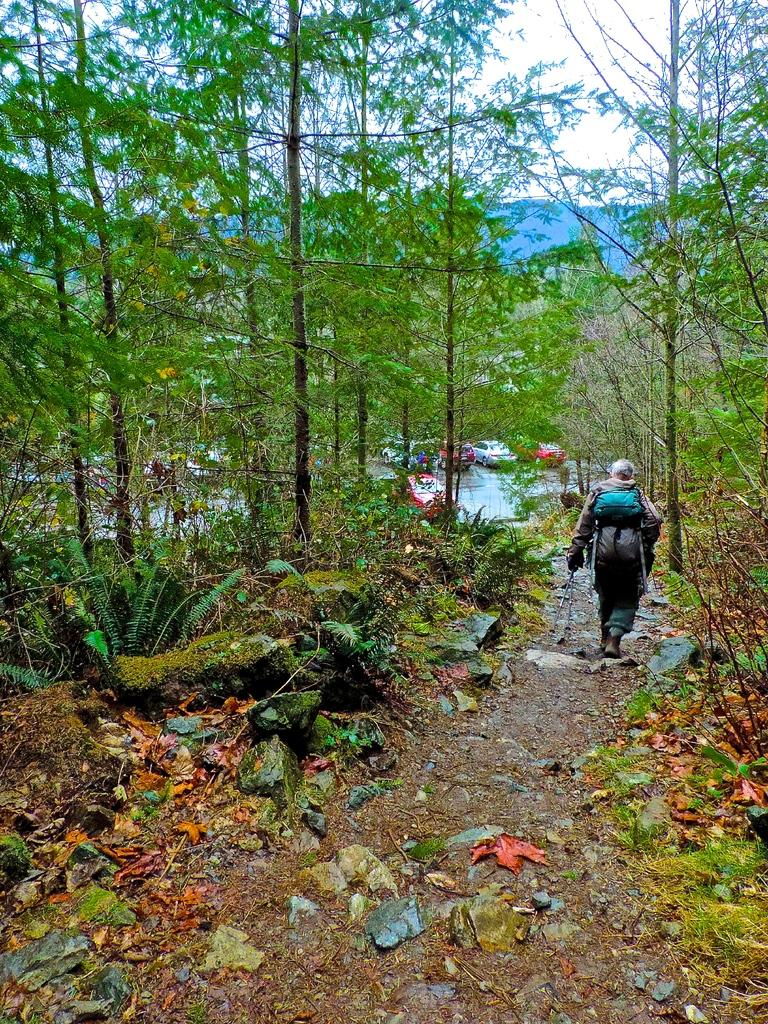Who is present in the image? There is a person in the image. What is the person doing in the image? The person is walking on a path. What is the person carrying while walking on the path? The person is carrying a backpack. What can be seen on both sides of the path in the image? There are trees on both sides of the path. What is visible in the background of the image? There are parked cars in the background of the image. What type of square is being used for arithmetic calculations in the image? There is no square or arithmetic calculations present in the image. How many feet does the person have in the image? The image does not show the person's feet, so it is impossible to determine the number of feet they have. 